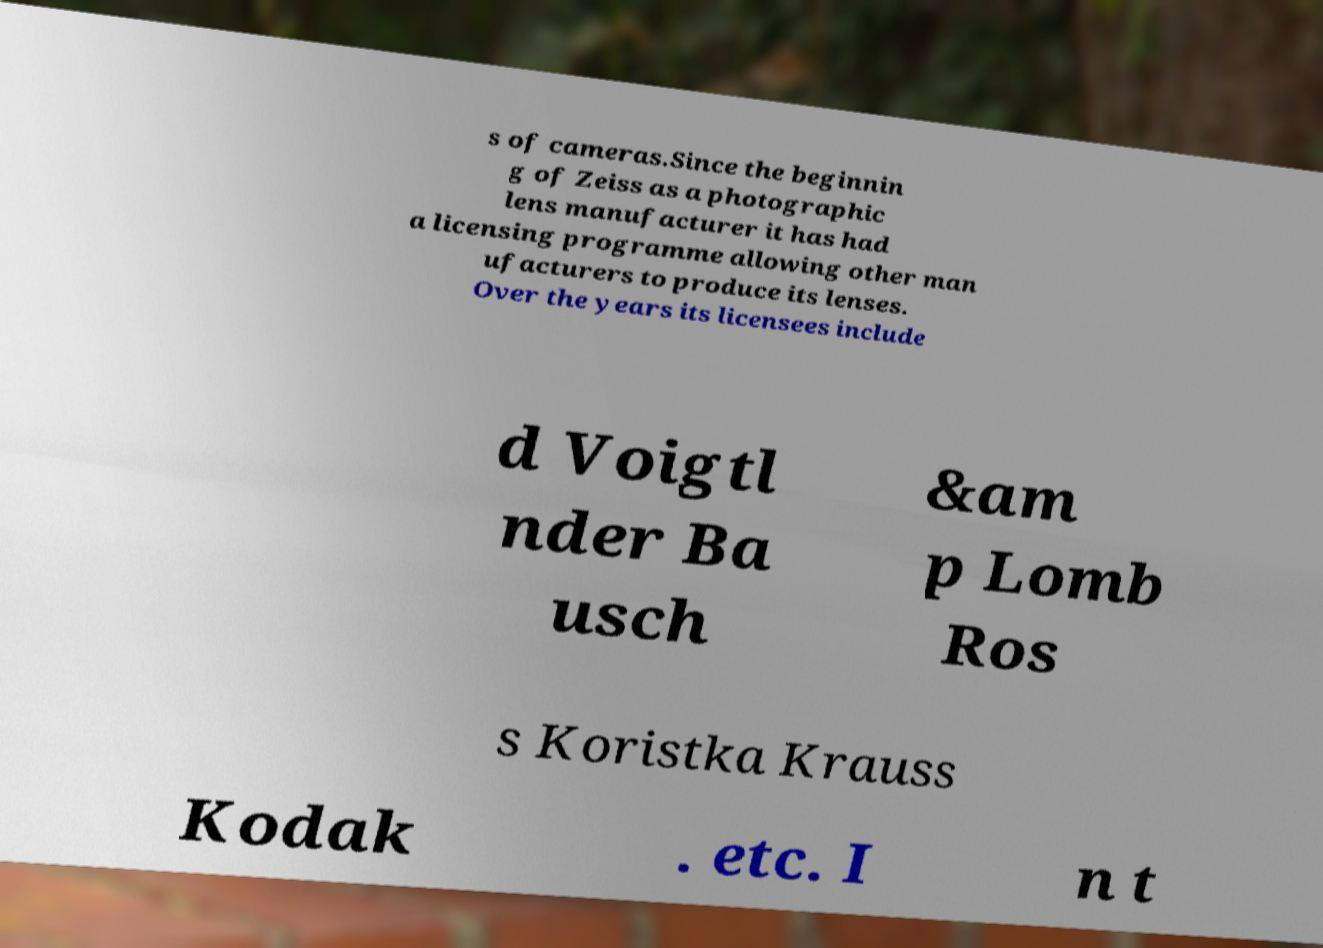Could you assist in decoding the text presented in this image and type it out clearly? s of cameras.Since the beginnin g of Zeiss as a photographic lens manufacturer it has had a licensing programme allowing other man ufacturers to produce its lenses. Over the years its licensees include d Voigtl nder Ba usch &am p Lomb Ros s Koristka Krauss Kodak . etc. I n t 